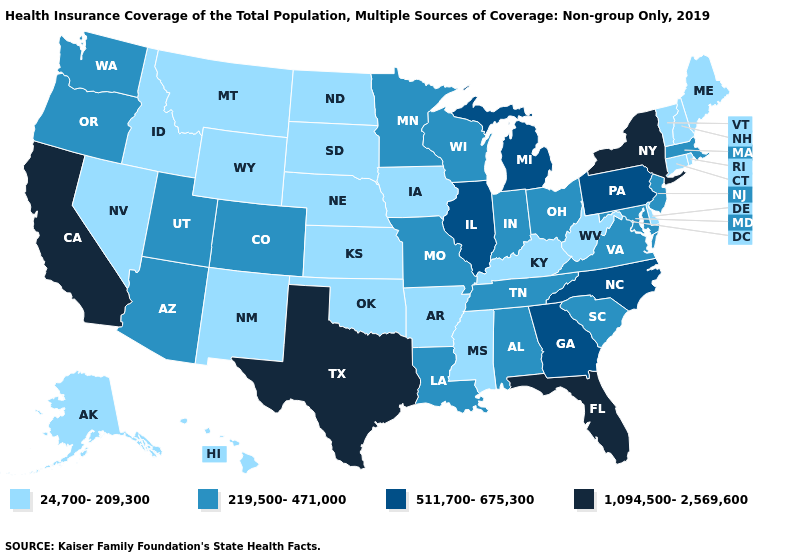Does Massachusetts have the lowest value in the Northeast?
Keep it brief. No. Name the states that have a value in the range 1,094,500-2,569,600?
Concise answer only. California, Florida, New York, Texas. Name the states that have a value in the range 219,500-471,000?
Write a very short answer. Alabama, Arizona, Colorado, Indiana, Louisiana, Maryland, Massachusetts, Minnesota, Missouri, New Jersey, Ohio, Oregon, South Carolina, Tennessee, Utah, Virginia, Washington, Wisconsin. Among the states that border New Hampshire , which have the lowest value?
Be succinct. Maine, Vermont. What is the value of New Hampshire?
Answer briefly. 24,700-209,300. What is the value of New Mexico?
Write a very short answer. 24,700-209,300. How many symbols are there in the legend?
Short answer required. 4. Among the states that border Virginia , does Kentucky have the lowest value?
Keep it brief. Yes. Name the states that have a value in the range 1,094,500-2,569,600?
Be succinct. California, Florida, New York, Texas. Name the states that have a value in the range 1,094,500-2,569,600?
Concise answer only. California, Florida, New York, Texas. Does the first symbol in the legend represent the smallest category?
Keep it brief. Yes. Does Florida have the lowest value in the South?
Give a very brief answer. No. Name the states that have a value in the range 1,094,500-2,569,600?
Be succinct. California, Florida, New York, Texas. Name the states that have a value in the range 219,500-471,000?
Concise answer only. Alabama, Arizona, Colorado, Indiana, Louisiana, Maryland, Massachusetts, Minnesota, Missouri, New Jersey, Ohio, Oregon, South Carolina, Tennessee, Utah, Virginia, Washington, Wisconsin. Name the states that have a value in the range 219,500-471,000?
Be succinct. Alabama, Arizona, Colorado, Indiana, Louisiana, Maryland, Massachusetts, Minnesota, Missouri, New Jersey, Ohio, Oregon, South Carolina, Tennessee, Utah, Virginia, Washington, Wisconsin. 